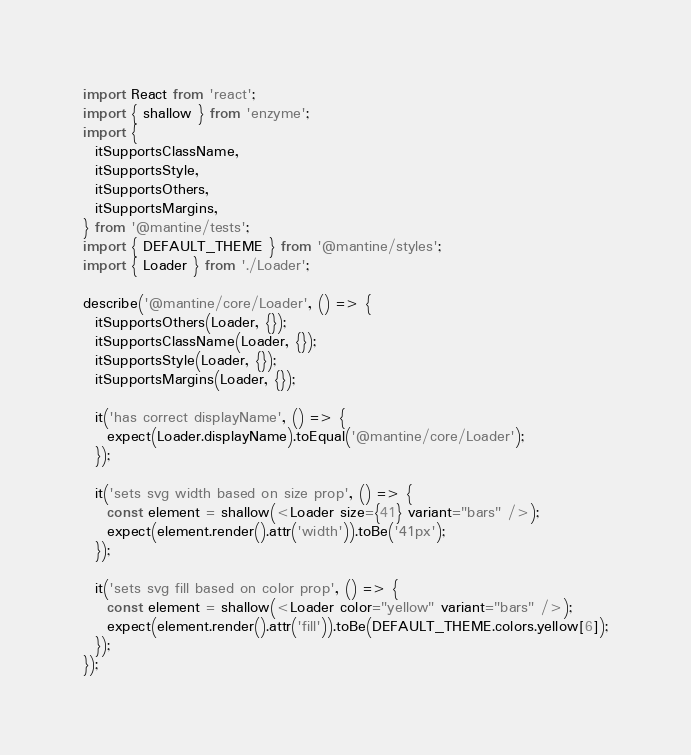Convert code to text. <code><loc_0><loc_0><loc_500><loc_500><_TypeScript_>import React from 'react';
import { shallow } from 'enzyme';
import {
  itSupportsClassName,
  itSupportsStyle,
  itSupportsOthers,
  itSupportsMargins,
} from '@mantine/tests';
import { DEFAULT_THEME } from '@mantine/styles';
import { Loader } from './Loader';

describe('@mantine/core/Loader', () => {
  itSupportsOthers(Loader, {});
  itSupportsClassName(Loader, {});
  itSupportsStyle(Loader, {});
  itSupportsMargins(Loader, {});

  it('has correct displayName', () => {
    expect(Loader.displayName).toEqual('@mantine/core/Loader');
  });

  it('sets svg width based on size prop', () => {
    const element = shallow(<Loader size={41} variant="bars" />);
    expect(element.render().attr('width')).toBe('41px');
  });

  it('sets svg fill based on color prop', () => {
    const element = shallow(<Loader color="yellow" variant="bars" />);
    expect(element.render().attr('fill')).toBe(DEFAULT_THEME.colors.yellow[6]);
  });
});
</code> 